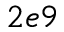Convert formula to latex. <formula><loc_0><loc_0><loc_500><loc_500>2 e 9</formula> 